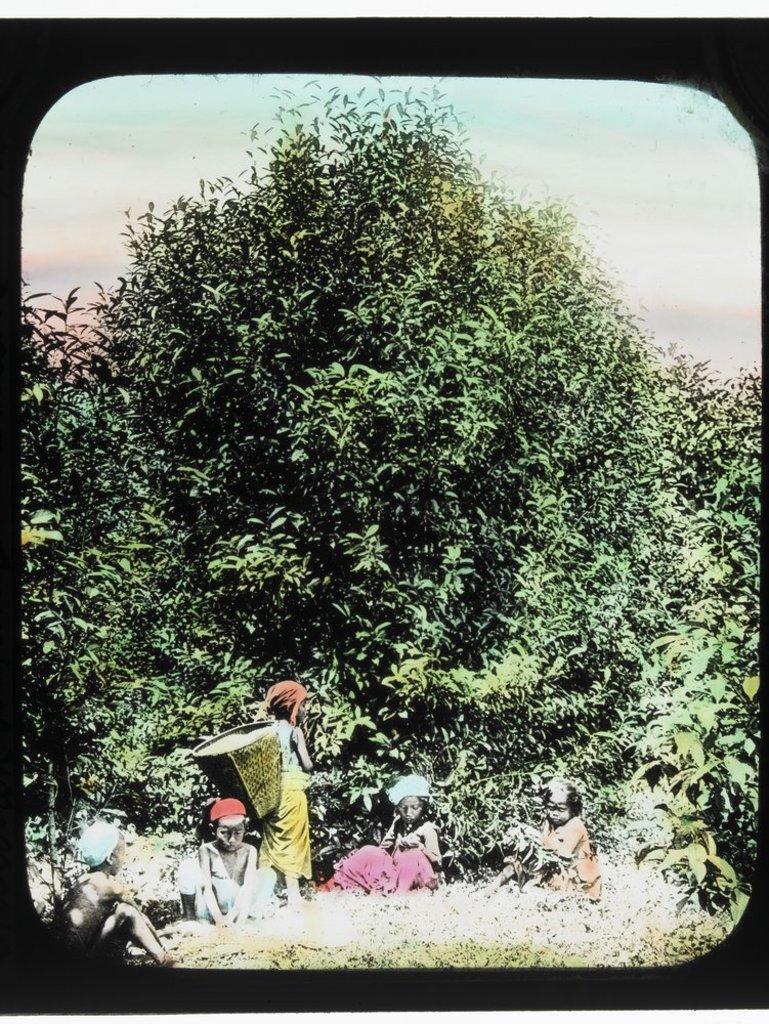Can you describe this image briefly? In this image we can see few people. There is a sky in the image. There are plants in the image. There is a tree in the image. 